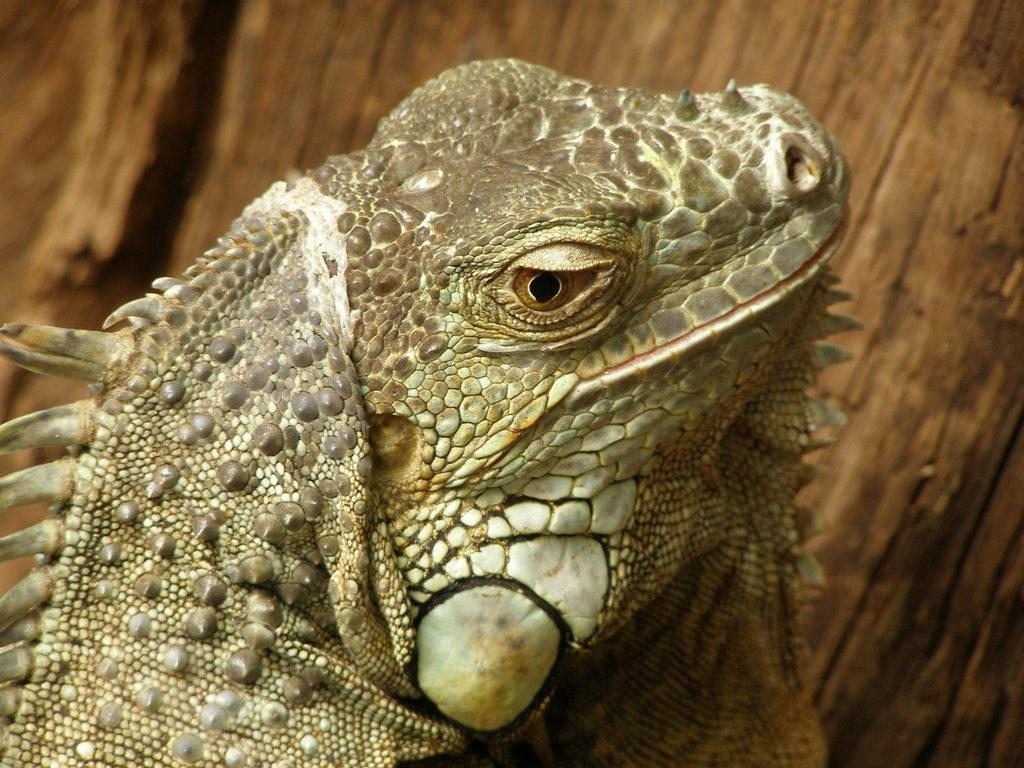What type of animal is in the image? There is a reptile in the image. Can you describe the background of the image? The background of the image is blurred. What type of playground equipment can be seen in the image? There is no playground equipment present in the image; it features a reptile with a blurred background. 